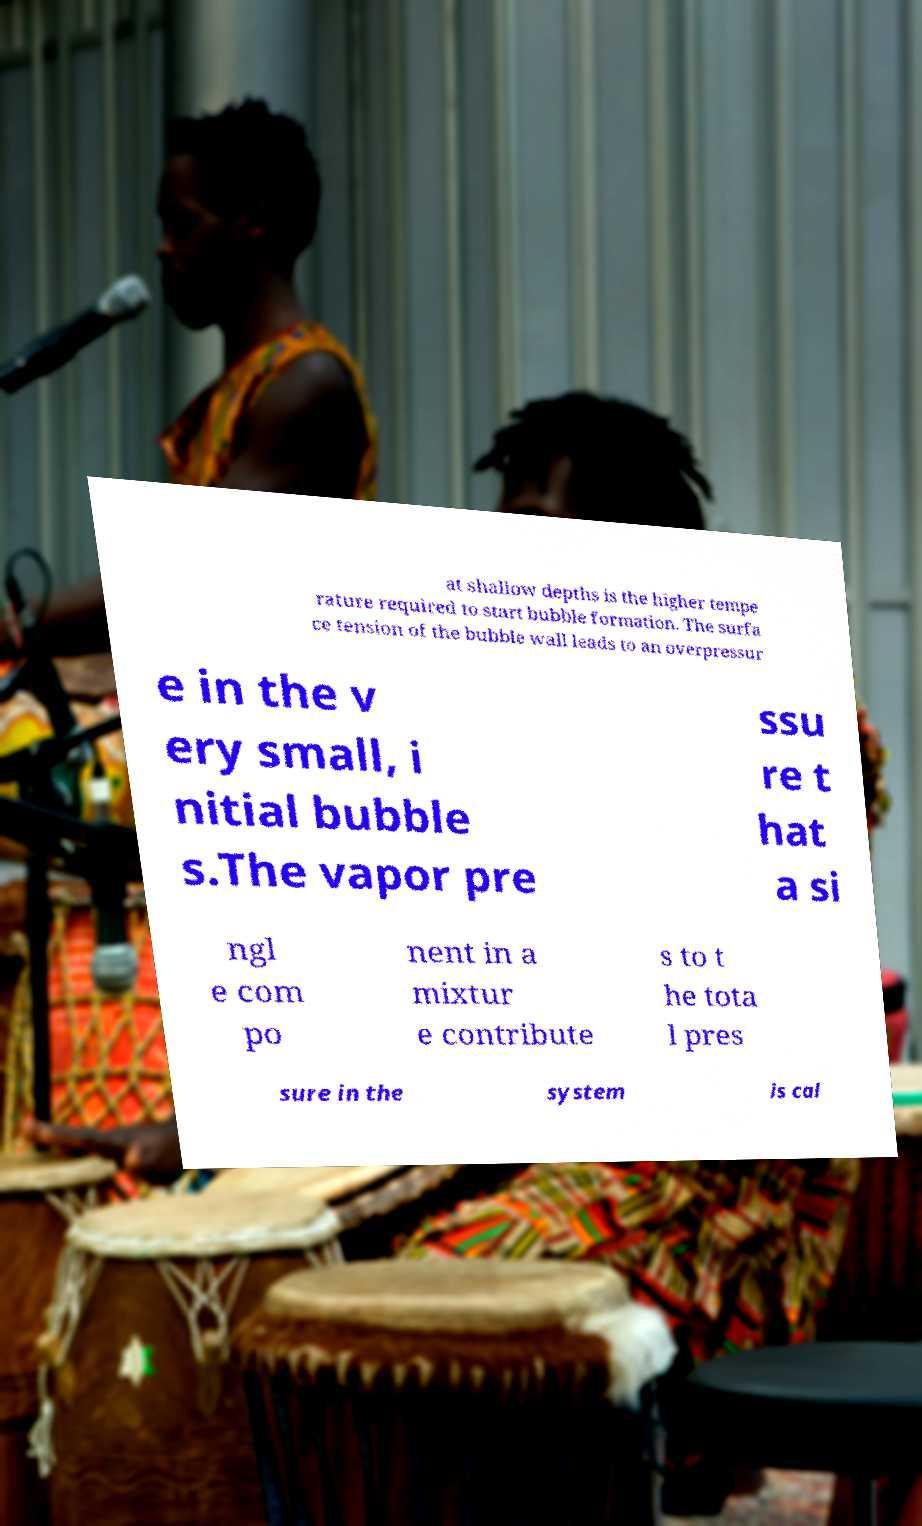Please read and relay the text visible in this image. What does it say? at shallow depths is the higher tempe rature required to start bubble formation. The surfa ce tension of the bubble wall leads to an overpressur e in the v ery small, i nitial bubble s.The vapor pre ssu re t hat a si ngl e com po nent in a mixtur e contribute s to t he tota l pres sure in the system is cal 